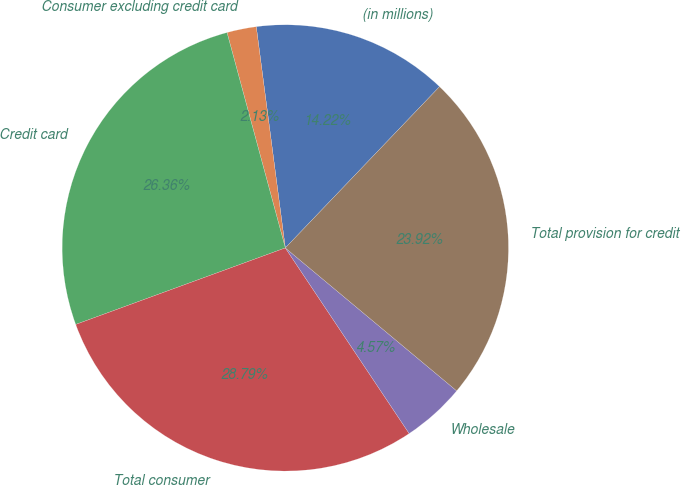<chart> <loc_0><loc_0><loc_500><loc_500><pie_chart><fcel>(in millions)<fcel>Consumer excluding credit card<fcel>Credit card<fcel>Total consumer<fcel>Wholesale<fcel>Total provision for credit<nl><fcel>14.22%<fcel>2.13%<fcel>26.36%<fcel>28.79%<fcel>4.57%<fcel>23.92%<nl></chart> 